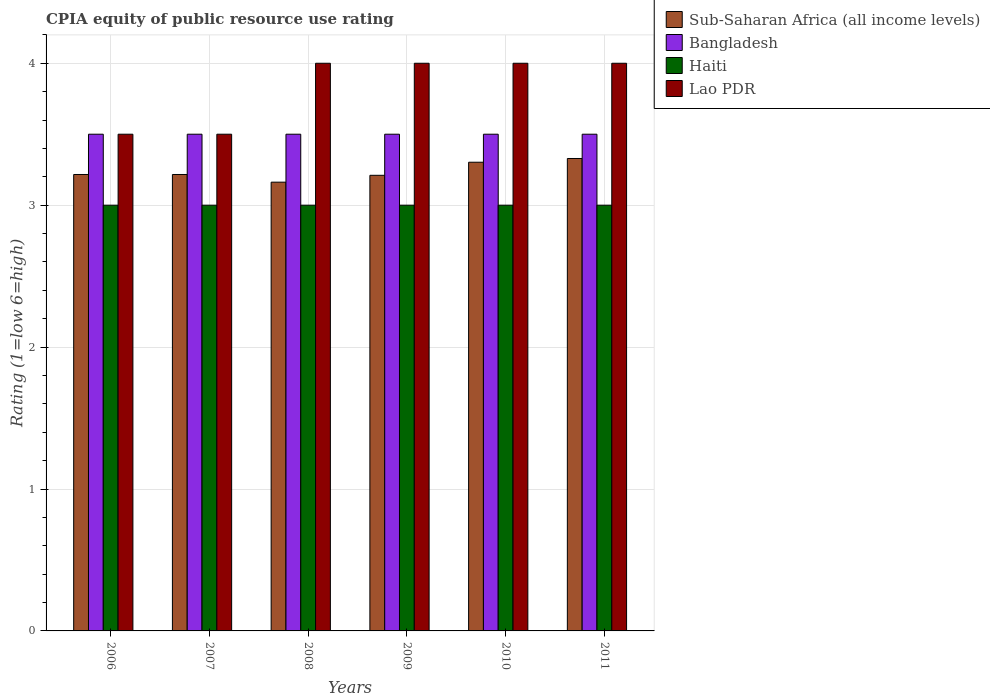How many different coloured bars are there?
Make the answer very short. 4. Are the number of bars on each tick of the X-axis equal?
Your answer should be very brief. Yes. How many bars are there on the 6th tick from the right?
Your answer should be very brief. 4. What is the label of the 4th group of bars from the left?
Give a very brief answer. 2009. In how many cases, is the number of bars for a given year not equal to the number of legend labels?
Offer a very short reply. 0. What is the CPIA rating in Sub-Saharan Africa (all income levels) in 2008?
Offer a very short reply. 3.16. In which year was the CPIA rating in Haiti maximum?
Your response must be concise. 2006. In which year was the CPIA rating in Lao PDR minimum?
Your answer should be very brief. 2006. What is the difference between the CPIA rating in Lao PDR in 2008 and that in 2011?
Give a very brief answer. 0. What is the average CPIA rating in Bangladesh per year?
Your answer should be compact. 3.5. In the year 2008, what is the difference between the CPIA rating in Bangladesh and CPIA rating in Haiti?
Keep it short and to the point. 0.5. In how many years, is the CPIA rating in Bangladesh greater than 0.8?
Keep it short and to the point. 6. What is the ratio of the CPIA rating in Lao PDR in 2006 to that in 2008?
Provide a short and direct response. 0.88. Is the CPIA rating in Haiti in 2006 less than that in 2010?
Your answer should be very brief. No. In how many years, is the CPIA rating in Bangladesh greater than the average CPIA rating in Bangladesh taken over all years?
Your answer should be compact. 0. Is it the case that in every year, the sum of the CPIA rating in Bangladesh and CPIA rating in Haiti is greater than the sum of CPIA rating in Lao PDR and CPIA rating in Sub-Saharan Africa (all income levels)?
Make the answer very short. Yes. What does the 1st bar from the left in 2010 represents?
Your answer should be very brief. Sub-Saharan Africa (all income levels). What does the 1st bar from the right in 2006 represents?
Keep it short and to the point. Lao PDR. How many bars are there?
Keep it short and to the point. 24. How many years are there in the graph?
Your answer should be compact. 6. Where does the legend appear in the graph?
Provide a succinct answer. Top right. How many legend labels are there?
Offer a very short reply. 4. How are the legend labels stacked?
Your response must be concise. Vertical. What is the title of the graph?
Give a very brief answer. CPIA equity of public resource use rating. Does "Russian Federation" appear as one of the legend labels in the graph?
Your response must be concise. No. What is the label or title of the Y-axis?
Your answer should be very brief. Rating (1=low 6=high). What is the Rating (1=low 6=high) in Sub-Saharan Africa (all income levels) in 2006?
Provide a short and direct response. 3.22. What is the Rating (1=low 6=high) of Bangladesh in 2006?
Make the answer very short. 3.5. What is the Rating (1=low 6=high) in Haiti in 2006?
Offer a very short reply. 3. What is the Rating (1=low 6=high) of Sub-Saharan Africa (all income levels) in 2007?
Your answer should be very brief. 3.22. What is the Rating (1=low 6=high) in Bangladesh in 2007?
Keep it short and to the point. 3.5. What is the Rating (1=low 6=high) of Haiti in 2007?
Keep it short and to the point. 3. What is the Rating (1=low 6=high) in Sub-Saharan Africa (all income levels) in 2008?
Your answer should be compact. 3.16. What is the Rating (1=low 6=high) of Bangladesh in 2008?
Offer a terse response. 3.5. What is the Rating (1=low 6=high) in Lao PDR in 2008?
Make the answer very short. 4. What is the Rating (1=low 6=high) of Sub-Saharan Africa (all income levels) in 2009?
Provide a short and direct response. 3.21. What is the Rating (1=low 6=high) in Bangladesh in 2009?
Make the answer very short. 3.5. What is the Rating (1=low 6=high) of Haiti in 2009?
Your response must be concise. 3. What is the Rating (1=low 6=high) in Lao PDR in 2009?
Your answer should be very brief. 4. What is the Rating (1=low 6=high) in Sub-Saharan Africa (all income levels) in 2010?
Ensure brevity in your answer.  3.3. What is the Rating (1=low 6=high) of Bangladesh in 2010?
Offer a terse response. 3.5. What is the Rating (1=low 6=high) of Haiti in 2010?
Provide a succinct answer. 3. What is the Rating (1=low 6=high) of Lao PDR in 2010?
Ensure brevity in your answer.  4. What is the Rating (1=low 6=high) in Sub-Saharan Africa (all income levels) in 2011?
Your answer should be compact. 3.33. What is the Rating (1=low 6=high) of Haiti in 2011?
Offer a very short reply. 3. Across all years, what is the maximum Rating (1=low 6=high) of Sub-Saharan Africa (all income levels)?
Offer a terse response. 3.33. Across all years, what is the maximum Rating (1=low 6=high) of Lao PDR?
Provide a short and direct response. 4. Across all years, what is the minimum Rating (1=low 6=high) in Sub-Saharan Africa (all income levels)?
Offer a very short reply. 3.16. Across all years, what is the minimum Rating (1=low 6=high) of Haiti?
Your response must be concise. 3. What is the total Rating (1=low 6=high) in Sub-Saharan Africa (all income levels) in the graph?
Ensure brevity in your answer.  19.44. What is the total Rating (1=low 6=high) of Haiti in the graph?
Ensure brevity in your answer.  18. What is the difference between the Rating (1=low 6=high) of Lao PDR in 2006 and that in 2007?
Offer a very short reply. 0. What is the difference between the Rating (1=low 6=high) of Sub-Saharan Africa (all income levels) in 2006 and that in 2008?
Ensure brevity in your answer.  0.05. What is the difference between the Rating (1=low 6=high) of Bangladesh in 2006 and that in 2008?
Keep it short and to the point. 0. What is the difference between the Rating (1=low 6=high) in Lao PDR in 2006 and that in 2008?
Offer a very short reply. -0.5. What is the difference between the Rating (1=low 6=high) of Sub-Saharan Africa (all income levels) in 2006 and that in 2009?
Your response must be concise. 0.01. What is the difference between the Rating (1=low 6=high) in Haiti in 2006 and that in 2009?
Keep it short and to the point. 0. What is the difference between the Rating (1=low 6=high) of Lao PDR in 2006 and that in 2009?
Offer a terse response. -0.5. What is the difference between the Rating (1=low 6=high) in Sub-Saharan Africa (all income levels) in 2006 and that in 2010?
Ensure brevity in your answer.  -0.09. What is the difference between the Rating (1=low 6=high) of Sub-Saharan Africa (all income levels) in 2006 and that in 2011?
Ensure brevity in your answer.  -0.11. What is the difference between the Rating (1=low 6=high) of Haiti in 2006 and that in 2011?
Ensure brevity in your answer.  0. What is the difference between the Rating (1=low 6=high) of Sub-Saharan Africa (all income levels) in 2007 and that in 2008?
Offer a terse response. 0.05. What is the difference between the Rating (1=low 6=high) of Bangladesh in 2007 and that in 2008?
Keep it short and to the point. 0. What is the difference between the Rating (1=low 6=high) in Sub-Saharan Africa (all income levels) in 2007 and that in 2009?
Make the answer very short. 0.01. What is the difference between the Rating (1=low 6=high) of Haiti in 2007 and that in 2009?
Provide a succinct answer. 0. What is the difference between the Rating (1=low 6=high) of Sub-Saharan Africa (all income levels) in 2007 and that in 2010?
Your answer should be compact. -0.09. What is the difference between the Rating (1=low 6=high) of Bangladesh in 2007 and that in 2010?
Keep it short and to the point. 0. What is the difference between the Rating (1=low 6=high) in Haiti in 2007 and that in 2010?
Provide a succinct answer. 0. What is the difference between the Rating (1=low 6=high) of Sub-Saharan Africa (all income levels) in 2007 and that in 2011?
Make the answer very short. -0.11. What is the difference between the Rating (1=low 6=high) of Lao PDR in 2007 and that in 2011?
Your answer should be compact. -0.5. What is the difference between the Rating (1=low 6=high) of Sub-Saharan Africa (all income levels) in 2008 and that in 2009?
Your answer should be compact. -0.05. What is the difference between the Rating (1=low 6=high) of Haiti in 2008 and that in 2009?
Offer a terse response. 0. What is the difference between the Rating (1=low 6=high) of Sub-Saharan Africa (all income levels) in 2008 and that in 2010?
Provide a succinct answer. -0.14. What is the difference between the Rating (1=low 6=high) in Sub-Saharan Africa (all income levels) in 2008 and that in 2011?
Your answer should be compact. -0.17. What is the difference between the Rating (1=low 6=high) of Bangladesh in 2008 and that in 2011?
Keep it short and to the point. 0. What is the difference between the Rating (1=low 6=high) of Lao PDR in 2008 and that in 2011?
Give a very brief answer. 0. What is the difference between the Rating (1=low 6=high) in Sub-Saharan Africa (all income levels) in 2009 and that in 2010?
Offer a terse response. -0.09. What is the difference between the Rating (1=low 6=high) in Sub-Saharan Africa (all income levels) in 2009 and that in 2011?
Offer a terse response. -0.12. What is the difference between the Rating (1=low 6=high) of Sub-Saharan Africa (all income levels) in 2010 and that in 2011?
Make the answer very short. -0.03. What is the difference between the Rating (1=low 6=high) of Sub-Saharan Africa (all income levels) in 2006 and the Rating (1=low 6=high) of Bangladesh in 2007?
Your answer should be very brief. -0.28. What is the difference between the Rating (1=low 6=high) in Sub-Saharan Africa (all income levels) in 2006 and the Rating (1=low 6=high) in Haiti in 2007?
Provide a short and direct response. 0.22. What is the difference between the Rating (1=low 6=high) in Sub-Saharan Africa (all income levels) in 2006 and the Rating (1=low 6=high) in Lao PDR in 2007?
Keep it short and to the point. -0.28. What is the difference between the Rating (1=low 6=high) in Haiti in 2006 and the Rating (1=low 6=high) in Lao PDR in 2007?
Provide a succinct answer. -0.5. What is the difference between the Rating (1=low 6=high) in Sub-Saharan Africa (all income levels) in 2006 and the Rating (1=low 6=high) in Bangladesh in 2008?
Keep it short and to the point. -0.28. What is the difference between the Rating (1=low 6=high) of Sub-Saharan Africa (all income levels) in 2006 and the Rating (1=low 6=high) of Haiti in 2008?
Offer a very short reply. 0.22. What is the difference between the Rating (1=low 6=high) in Sub-Saharan Africa (all income levels) in 2006 and the Rating (1=low 6=high) in Lao PDR in 2008?
Provide a short and direct response. -0.78. What is the difference between the Rating (1=low 6=high) of Bangladesh in 2006 and the Rating (1=low 6=high) of Haiti in 2008?
Offer a very short reply. 0.5. What is the difference between the Rating (1=low 6=high) in Bangladesh in 2006 and the Rating (1=low 6=high) in Lao PDR in 2008?
Give a very brief answer. -0.5. What is the difference between the Rating (1=low 6=high) of Sub-Saharan Africa (all income levels) in 2006 and the Rating (1=low 6=high) of Bangladesh in 2009?
Ensure brevity in your answer.  -0.28. What is the difference between the Rating (1=low 6=high) in Sub-Saharan Africa (all income levels) in 2006 and the Rating (1=low 6=high) in Haiti in 2009?
Provide a short and direct response. 0.22. What is the difference between the Rating (1=low 6=high) in Sub-Saharan Africa (all income levels) in 2006 and the Rating (1=low 6=high) in Lao PDR in 2009?
Your response must be concise. -0.78. What is the difference between the Rating (1=low 6=high) in Haiti in 2006 and the Rating (1=low 6=high) in Lao PDR in 2009?
Keep it short and to the point. -1. What is the difference between the Rating (1=low 6=high) of Sub-Saharan Africa (all income levels) in 2006 and the Rating (1=low 6=high) of Bangladesh in 2010?
Your answer should be very brief. -0.28. What is the difference between the Rating (1=low 6=high) in Sub-Saharan Africa (all income levels) in 2006 and the Rating (1=low 6=high) in Haiti in 2010?
Your answer should be very brief. 0.22. What is the difference between the Rating (1=low 6=high) of Sub-Saharan Africa (all income levels) in 2006 and the Rating (1=low 6=high) of Lao PDR in 2010?
Ensure brevity in your answer.  -0.78. What is the difference between the Rating (1=low 6=high) of Haiti in 2006 and the Rating (1=low 6=high) of Lao PDR in 2010?
Keep it short and to the point. -1. What is the difference between the Rating (1=low 6=high) of Sub-Saharan Africa (all income levels) in 2006 and the Rating (1=low 6=high) of Bangladesh in 2011?
Give a very brief answer. -0.28. What is the difference between the Rating (1=low 6=high) of Sub-Saharan Africa (all income levels) in 2006 and the Rating (1=low 6=high) of Haiti in 2011?
Your answer should be very brief. 0.22. What is the difference between the Rating (1=low 6=high) in Sub-Saharan Africa (all income levels) in 2006 and the Rating (1=low 6=high) in Lao PDR in 2011?
Make the answer very short. -0.78. What is the difference between the Rating (1=low 6=high) of Haiti in 2006 and the Rating (1=low 6=high) of Lao PDR in 2011?
Your response must be concise. -1. What is the difference between the Rating (1=low 6=high) in Sub-Saharan Africa (all income levels) in 2007 and the Rating (1=low 6=high) in Bangladesh in 2008?
Offer a terse response. -0.28. What is the difference between the Rating (1=low 6=high) of Sub-Saharan Africa (all income levels) in 2007 and the Rating (1=low 6=high) of Haiti in 2008?
Your response must be concise. 0.22. What is the difference between the Rating (1=low 6=high) of Sub-Saharan Africa (all income levels) in 2007 and the Rating (1=low 6=high) of Lao PDR in 2008?
Provide a short and direct response. -0.78. What is the difference between the Rating (1=low 6=high) of Bangladesh in 2007 and the Rating (1=low 6=high) of Haiti in 2008?
Keep it short and to the point. 0.5. What is the difference between the Rating (1=low 6=high) in Bangladesh in 2007 and the Rating (1=low 6=high) in Lao PDR in 2008?
Your answer should be very brief. -0.5. What is the difference between the Rating (1=low 6=high) in Haiti in 2007 and the Rating (1=low 6=high) in Lao PDR in 2008?
Offer a terse response. -1. What is the difference between the Rating (1=low 6=high) in Sub-Saharan Africa (all income levels) in 2007 and the Rating (1=low 6=high) in Bangladesh in 2009?
Provide a succinct answer. -0.28. What is the difference between the Rating (1=low 6=high) of Sub-Saharan Africa (all income levels) in 2007 and the Rating (1=low 6=high) of Haiti in 2009?
Your answer should be very brief. 0.22. What is the difference between the Rating (1=low 6=high) of Sub-Saharan Africa (all income levels) in 2007 and the Rating (1=low 6=high) of Lao PDR in 2009?
Give a very brief answer. -0.78. What is the difference between the Rating (1=low 6=high) in Haiti in 2007 and the Rating (1=low 6=high) in Lao PDR in 2009?
Make the answer very short. -1. What is the difference between the Rating (1=low 6=high) in Sub-Saharan Africa (all income levels) in 2007 and the Rating (1=low 6=high) in Bangladesh in 2010?
Keep it short and to the point. -0.28. What is the difference between the Rating (1=low 6=high) in Sub-Saharan Africa (all income levels) in 2007 and the Rating (1=low 6=high) in Haiti in 2010?
Make the answer very short. 0.22. What is the difference between the Rating (1=low 6=high) of Sub-Saharan Africa (all income levels) in 2007 and the Rating (1=low 6=high) of Lao PDR in 2010?
Keep it short and to the point. -0.78. What is the difference between the Rating (1=low 6=high) in Bangladesh in 2007 and the Rating (1=low 6=high) in Haiti in 2010?
Make the answer very short. 0.5. What is the difference between the Rating (1=low 6=high) of Haiti in 2007 and the Rating (1=low 6=high) of Lao PDR in 2010?
Give a very brief answer. -1. What is the difference between the Rating (1=low 6=high) of Sub-Saharan Africa (all income levels) in 2007 and the Rating (1=low 6=high) of Bangladesh in 2011?
Make the answer very short. -0.28. What is the difference between the Rating (1=low 6=high) of Sub-Saharan Africa (all income levels) in 2007 and the Rating (1=low 6=high) of Haiti in 2011?
Your answer should be compact. 0.22. What is the difference between the Rating (1=low 6=high) in Sub-Saharan Africa (all income levels) in 2007 and the Rating (1=low 6=high) in Lao PDR in 2011?
Provide a short and direct response. -0.78. What is the difference between the Rating (1=low 6=high) of Bangladesh in 2007 and the Rating (1=low 6=high) of Haiti in 2011?
Offer a very short reply. 0.5. What is the difference between the Rating (1=low 6=high) in Haiti in 2007 and the Rating (1=low 6=high) in Lao PDR in 2011?
Your answer should be compact. -1. What is the difference between the Rating (1=low 6=high) of Sub-Saharan Africa (all income levels) in 2008 and the Rating (1=low 6=high) of Bangladesh in 2009?
Ensure brevity in your answer.  -0.34. What is the difference between the Rating (1=low 6=high) of Sub-Saharan Africa (all income levels) in 2008 and the Rating (1=low 6=high) of Haiti in 2009?
Offer a very short reply. 0.16. What is the difference between the Rating (1=low 6=high) in Sub-Saharan Africa (all income levels) in 2008 and the Rating (1=low 6=high) in Lao PDR in 2009?
Provide a succinct answer. -0.84. What is the difference between the Rating (1=low 6=high) of Bangladesh in 2008 and the Rating (1=low 6=high) of Lao PDR in 2009?
Offer a terse response. -0.5. What is the difference between the Rating (1=low 6=high) of Sub-Saharan Africa (all income levels) in 2008 and the Rating (1=low 6=high) of Bangladesh in 2010?
Your response must be concise. -0.34. What is the difference between the Rating (1=low 6=high) of Sub-Saharan Africa (all income levels) in 2008 and the Rating (1=low 6=high) of Haiti in 2010?
Offer a terse response. 0.16. What is the difference between the Rating (1=low 6=high) of Sub-Saharan Africa (all income levels) in 2008 and the Rating (1=low 6=high) of Lao PDR in 2010?
Offer a very short reply. -0.84. What is the difference between the Rating (1=low 6=high) of Bangladesh in 2008 and the Rating (1=low 6=high) of Haiti in 2010?
Give a very brief answer. 0.5. What is the difference between the Rating (1=low 6=high) in Sub-Saharan Africa (all income levels) in 2008 and the Rating (1=low 6=high) in Bangladesh in 2011?
Provide a succinct answer. -0.34. What is the difference between the Rating (1=low 6=high) in Sub-Saharan Africa (all income levels) in 2008 and the Rating (1=low 6=high) in Haiti in 2011?
Provide a short and direct response. 0.16. What is the difference between the Rating (1=low 6=high) in Sub-Saharan Africa (all income levels) in 2008 and the Rating (1=low 6=high) in Lao PDR in 2011?
Provide a short and direct response. -0.84. What is the difference between the Rating (1=low 6=high) of Bangladesh in 2008 and the Rating (1=low 6=high) of Haiti in 2011?
Make the answer very short. 0.5. What is the difference between the Rating (1=low 6=high) of Haiti in 2008 and the Rating (1=low 6=high) of Lao PDR in 2011?
Give a very brief answer. -1. What is the difference between the Rating (1=low 6=high) in Sub-Saharan Africa (all income levels) in 2009 and the Rating (1=low 6=high) in Bangladesh in 2010?
Keep it short and to the point. -0.29. What is the difference between the Rating (1=low 6=high) of Sub-Saharan Africa (all income levels) in 2009 and the Rating (1=low 6=high) of Haiti in 2010?
Ensure brevity in your answer.  0.21. What is the difference between the Rating (1=low 6=high) in Sub-Saharan Africa (all income levels) in 2009 and the Rating (1=low 6=high) in Lao PDR in 2010?
Offer a very short reply. -0.79. What is the difference between the Rating (1=low 6=high) of Sub-Saharan Africa (all income levels) in 2009 and the Rating (1=low 6=high) of Bangladesh in 2011?
Your answer should be very brief. -0.29. What is the difference between the Rating (1=low 6=high) in Sub-Saharan Africa (all income levels) in 2009 and the Rating (1=low 6=high) in Haiti in 2011?
Give a very brief answer. 0.21. What is the difference between the Rating (1=low 6=high) of Sub-Saharan Africa (all income levels) in 2009 and the Rating (1=low 6=high) of Lao PDR in 2011?
Make the answer very short. -0.79. What is the difference between the Rating (1=low 6=high) in Bangladesh in 2009 and the Rating (1=low 6=high) in Lao PDR in 2011?
Keep it short and to the point. -0.5. What is the difference between the Rating (1=low 6=high) of Sub-Saharan Africa (all income levels) in 2010 and the Rating (1=low 6=high) of Bangladesh in 2011?
Provide a short and direct response. -0.2. What is the difference between the Rating (1=low 6=high) of Sub-Saharan Africa (all income levels) in 2010 and the Rating (1=low 6=high) of Haiti in 2011?
Keep it short and to the point. 0.3. What is the difference between the Rating (1=low 6=high) in Sub-Saharan Africa (all income levels) in 2010 and the Rating (1=low 6=high) in Lao PDR in 2011?
Your answer should be very brief. -0.7. What is the difference between the Rating (1=low 6=high) in Bangladesh in 2010 and the Rating (1=low 6=high) in Haiti in 2011?
Your answer should be compact. 0.5. What is the difference between the Rating (1=low 6=high) of Bangladesh in 2010 and the Rating (1=low 6=high) of Lao PDR in 2011?
Offer a very short reply. -0.5. What is the difference between the Rating (1=low 6=high) in Haiti in 2010 and the Rating (1=low 6=high) in Lao PDR in 2011?
Provide a short and direct response. -1. What is the average Rating (1=low 6=high) of Sub-Saharan Africa (all income levels) per year?
Give a very brief answer. 3.24. What is the average Rating (1=low 6=high) of Lao PDR per year?
Provide a succinct answer. 3.83. In the year 2006, what is the difference between the Rating (1=low 6=high) in Sub-Saharan Africa (all income levels) and Rating (1=low 6=high) in Bangladesh?
Offer a terse response. -0.28. In the year 2006, what is the difference between the Rating (1=low 6=high) of Sub-Saharan Africa (all income levels) and Rating (1=low 6=high) of Haiti?
Your response must be concise. 0.22. In the year 2006, what is the difference between the Rating (1=low 6=high) of Sub-Saharan Africa (all income levels) and Rating (1=low 6=high) of Lao PDR?
Provide a succinct answer. -0.28. In the year 2006, what is the difference between the Rating (1=low 6=high) of Bangladesh and Rating (1=low 6=high) of Haiti?
Your response must be concise. 0.5. In the year 2007, what is the difference between the Rating (1=low 6=high) of Sub-Saharan Africa (all income levels) and Rating (1=low 6=high) of Bangladesh?
Give a very brief answer. -0.28. In the year 2007, what is the difference between the Rating (1=low 6=high) of Sub-Saharan Africa (all income levels) and Rating (1=low 6=high) of Haiti?
Offer a very short reply. 0.22. In the year 2007, what is the difference between the Rating (1=low 6=high) in Sub-Saharan Africa (all income levels) and Rating (1=low 6=high) in Lao PDR?
Ensure brevity in your answer.  -0.28. In the year 2008, what is the difference between the Rating (1=low 6=high) in Sub-Saharan Africa (all income levels) and Rating (1=low 6=high) in Bangladesh?
Ensure brevity in your answer.  -0.34. In the year 2008, what is the difference between the Rating (1=low 6=high) in Sub-Saharan Africa (all income levels) and Rating (1=low 6=high) in Haiti?
Your response must be concise. 0.16. In the year 2008, what is the difference between the Rating (1=low 6=high) of Sub-Saharan Africa (all income levels) and Rating (1=low 6=high) of Lao PDR?
Offer a very short reply. -0.84. In the year 2008, what is the difference between the Rating (1=low 6=high) of Bangladesh and Rating (1=low 6=high) of Haiti?
Provide a short and direct response. 0.5. In the year 2009, what is the difference between the Rating (1=low 6=high) in Sub-Saharan Africa (all income levels) and Rating (1=low 6=high) in Bangladesh?
Your answer should be compact. -0.29. In the year 2009, what is the difference between the Rating (1=low 6=high) of Sub-Saharan Africa (all income levels) and Rating (1=low 6=high) of Haiti?
Your response must be concise. 0.21. In the year 2009, what is the difference between the Rating (1=low 6=high) of Sub-Saharan Africa (all income levels) and Rating (1=low 6=high) of Lao PDR?
Keep it short and to the point. -0.79. In the year 2009, what is the difference between the Rating (1=low 6=high) in Bangladesh and Rating (1=low 6=high) in Haiti?
Provide a short and direct response. 0.5. In the year 2009, what is the difference between the Rating (1=low 6=high) of Haiti and Rating (1=low 6=high) of Lao PDR?
Make the answer very short. -1. In the year 2010, what is the difference between the Rating (1=low 6=high) in Sub-Saharan Africa (all income levels) and Rating (1=low 6=high) in Bangladesh?
Provide a short and direct response. -0.2. In the year 2010, what is the difference between the Rating (1=low 6=high) in Sub-Saharan Africa (all income levels) and Rating (1=low 6=high) in Haiti?
Ensure brevity in your answer.  0.3. In the year 2010, what is the difference between the Rating (1=low 6=high) in Sub-Saharan Africa (all income levels) and Rating (1=low 6=high) in Lao PDR?
Provide a succinct answer. -0.7. In the year 2010, what is the difference between the Rating (1=low 6=high) in Bangladesh and Rating (1=low 6=high) in Haiti?
Provide a succinct answer. 0.5. In the year 2010, what is the difference between the Rating (1=low 6=high) in Bangladesh and Rating (1=low 6=high) in Lao PDR?
Ensure brevity in your answer.  -0.5. In the year 2010, what is the difference between the Rating (1=low 6=high) of Haiti and Rating (1=low 6=high) of Lao PDR?
Ensure brevity in your answer.  -1. In the year 2011, what is the difference between the Rating (1=low 6=high) of Sub-Saharan Africa (all income levels) and Rating (1=low 6=high) of Bangladesh?
Keep it short and to the point. -0.17. In the year 2011, what is the difference between the Rating (1=low 6=high) of Sub-Saharan Africa (all income levels) and Rating (1=low 6=high) of Haiti?
Offer a terse response. 0.33. In the year 2011, what is the difference between the Rating (1=low 6=high) of Sub-Saharan Africa (all income levels) and Rating (1=low 6=high) of Lao PDR?
Give a very brief answer. -0.67. In the year 2011, what is the difference between the Rating (1=low 6=high) in Bangladesh and Rating (1=low 6=high) in Lao PDR?
Your answer should be compact. -0.5. What is the ratio of the Rating (1=low 6=high) of Sub-Saharan Africa (all income levels) in 2006 to that in 2007?
Provide a succinct answer. 1. What is the ratio of the Rating (1=low 6=high) in Bangladesh in 2006 to that in 2007?
Your response must be concise. 1. What is the ratio of the Rating (1=low 6=high) of Haiti in 2006 to that in 2007?
Give a very brief answer. 1. What is the ratio of the Rating (1=low 6=high) in Lao PDR in 2006 to that in 2007?
Provide a succinct answer. 1. What is the ratio of the Rating (1=low 6=high) in Sub-Saharan Africa (all income levels) in 2006 to that in 2008?
Your answer should be compact. 1.02. What is the ratio of the Rating (1=low 6=high) of Bangladesh in 2006 to that in 2008?
Ensure brevity in your answer.  1. What is the ratio of the Rating (1=low 6=high) in Haiti in 2006 to that in 2008?
Provide a succinct answer. 1. What is the ratio of the Rating (1=low 6=high) in Lao PDR in 2006 to that in 2008?
Your answer should be very brief. 0.88. What is the ratio of the Rating (1=low 6=high) of Sub-Saharan Africa (all income levels) in 2006 to that in 2009?
Keep it short and to the point. 1. What is the ratio of the Rating (1=low 6=high) of Lao PDR in 2006 to that in 2009?
Provide a short and direct response. 0.88. What is the ratio of the Rating (1=low 6=high) of Sub-Saharan Africa (all income levels) in 2006 to that in 2010?
Make the answer very short. 0.97. What is the ratio of the Rating (1=low 6=high) in Lao PDR in 2006 to that in 2010?
Offer a terse response. 0.88. What is the ratio of the Rating (1=low 6=high) in Sub-Saharan Africa (all income levels) in 2006 to that in 2011?
Provide a short and direct response. 0.97. What is the ratio of the Rating (1=low 6=high) in Bangladesh in 2006 to that in 2011?
Give a very brief answer. 1. What is the ratio of the Rating (1=low 6=high) of Haiti in 2006 to that in 2011?
Ensure brevity in your answer.  1. What is the ratio of the Rating (1=low 6=high) of Lao PDR in 2006 to that in 2011?
Your answer should be compact. 0.88. What is the ratio of the Rating (1=low 6=high) in Sub-Saharan Africa (all income levels) in 2007 to that in 2008?
Provide a short and direct response. 1.02. What is the ratio of the Rating (1=low 6=high) in Lao PDR in 2007 to that in 2008?
Give a very brief answer. 0.88. What is the ratio of the Rating (1=low 6=high) in Bangladesh in 2007 to that in 2009?
Provide a short and direct response. 1. What is the ratio of the Rating (1=low 6=high) of Haiti in 2007 to that in 2009?
Offer a terse response. 1. What is the ratio of the Rating (1=low 6=high) in Lao PDR in 2007 to that in 2009?
Offer a very short reply. 0.88. What is the ratio of the Rating (1=low 6=high) in Sub-Saharan Africa (all income levels) in 2007 to that in 2010?
Provide a succinct answer. 0.97. What is the ratio of the Rating (1=low 6=high) of Haiti in 2007 to that in 2010?
Offer a terse response. 1. What is the ratio of the Rating (1=low 6=high) in Lao PDR in 2007 to that in 2010?
Your answer should be compact. 0.88. What is the ratio of the Rating (1=low 6=high) of Sub-Saharan Africa (all income levels) in 2007 to that in 2011?
Your answer should be very brief. 0.97. What is the ratio of the Rating (1=low 6=high) of Bangladesh in 2007 to that in 2011?
Offer a very short reply. 1. What is the ratio of the Rating (1=low 6=high) of Haiti in 2007 to that in 2011?
Keep it short and to the point. 1. What is the ratio of the Rating (1=low 6=high) in Lao PDR in 2007 to that in 2011?
Ensure brevity in your answer.  0.88. What is the ratio of the Rating (1=low 6=high) in Sub-Saharan Africa (all income levels) in 2008 to that in 2009?
Give a very brief answer. 0.98. What is the ratio of the Rating (1=low 6=high) in Bangladesh in 2008 to that in 2009?
Offer a terse response. 1. What is the ratio of the Rating (1=low 6=high) in Haiti in 2008 to that in 2009?
Your answer should be compact. 1. What is the ratio of the Rating (1=low 6=high) of Lao PDR in 2008 to that in 2009?
Offer a terse response. 1. What is the ratio of the Rating (1=low 6=high) of Sub-Saharan Africa (all income levels) in 2008 to that in 2010?
Make the answer very short. 0.96. What is the ratio of the Rating (1=low 6=high) of Bangladesh in 2008 to that in 2010?
Make the answer very short. 1. What is the ratio of the Rating (1=low 6=high) of Lao PDR in 2008 to that in 2010?
Keep it short and to the point. 1. What is the ratio of the Rating (1=low 6=high) in Sub-Saharan Africa (all income levels) in 2008 to that in 2011?
Your answer should be very brief. 0.95. What is the ratio of the Rating (1=low 6=high) of Lao PDR in 2008 to that in 2011?
Ensure brevity in your answer.  1. What is the ratio of the Rating (1=low 6=high) in Sub-Saharan Africa (all income levels) in 2009 to that in 2010?
Offer a terse response. 0.97. What is the ratio of the Rating (1=low 6=high) of Sub-Saharan Africa (all income levels) in 2009 to that in 2011?
Make the answer very short. 0.96. What is the ratio of the Rating (1=low 6=high) in Bangladesh in 2009 to that in 2011?
Provide a short and direct response. 1. What is the ratio of the Rating (1=low 6=high) of Lao PDR in 2009 to that in 2011?
Your answer should be compact. 1. What is the ratio of the Rating (1=low 6=high) of Bangladesh in 2010 to that in 2011?
Provide a short and direct response. 1. What is the ratio of the Rating (1=low 6=high) of Haiti in 2010 to that in 2011?
Offer a terse response. 1. What is the difference between the highest and the second highest Rating (1=low 6=high) in Sub-Saharan Africa (all income levels)?
Your answer should be compact. 0.03. What is the difference between the highest and the second highest Rating (1=low 6=high) in Haiti?
Your response must be concise. 0. What is the difference between the highest and the second highest Rating (1=low 6=high) of Lao PDR?
Make the answer very short. 0. What is the difference between the highest and the lowest Rating (1=low 6=high) in Sub-Saharan Africa (all income levels)?
Give a very brief answer. 0.17. What is the difference between the highest and the lowest Rating (1=low 6=high) of Bangladesh?
Ensure brevity in your answer.  0. What is the difference between the highest and the lowest Rating (1=low 6=high) in Haiti?
Keep it short and to the point. 0. What is the difference between the highest and the lowest Rating (1=low 6=high) in Lao PDR?
Make the answer very short. 0.5. 